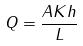Convert formula to latex. <formula><loc_0><loc_0><loc_500><loc_500>Q = \frac { A K h } { L }</formula> 